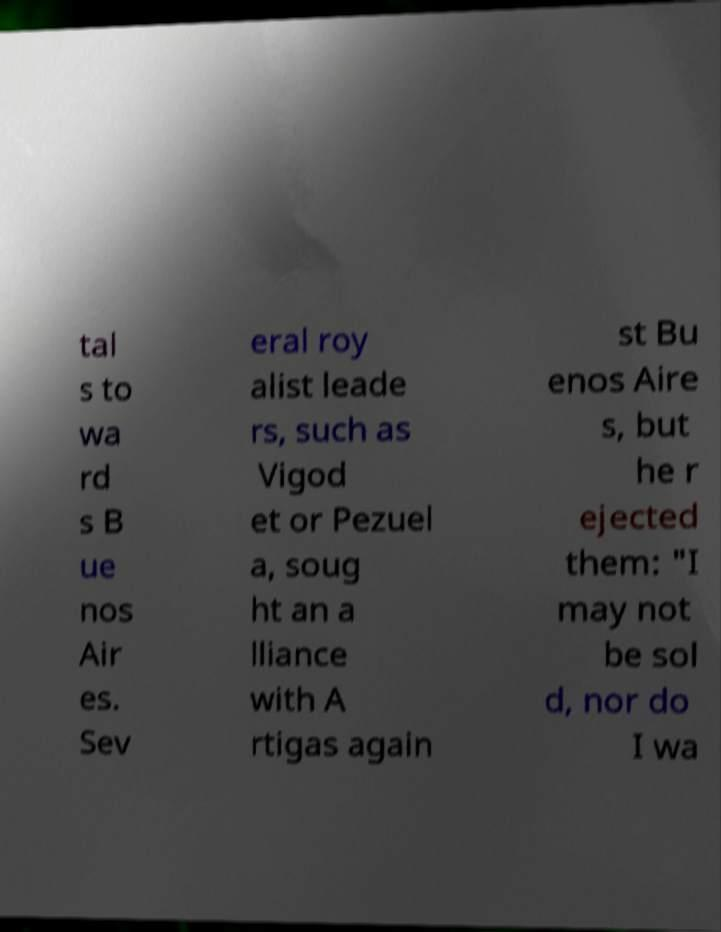Could you assist in decoding the text presented in this image and type it out clearly? tal s to wa rd s B ue nos Air es. Sev eral roy alist leade rs, such as Vigod et or Pezuel a, soug ht an a lliance with A rtigas again st Bu enos Aire s, but he r ejected them: "I may not be sol d, nor do I wa 